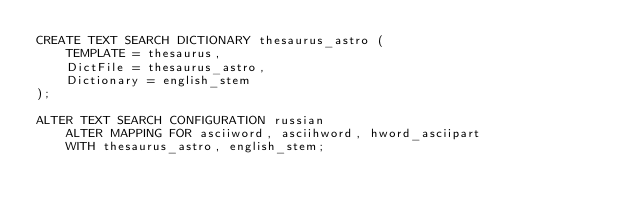<code> <loc_0><loc_0><loc_500><loc_500><_SQL_>CREATE TEXT SEARCH DICTIONARY thesaurus_astro (
    TEMPLATE = thesaurus,
    DictFile = thesaurus_astro,
    Dictionary = english_stem
);

ALTER TEXT SEARCH CONFIGURATION russian
    ALTER MAPPING FOR asciiword, asciihword, hword_asciipart
    WITH thesaurus_astro, english_stem;
</code> 